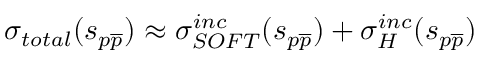<formula> <loc_0><loc_0><loc_500><loc_500>\sigma _ { t o t a l } ( s _ { p \overline { p } } ) \approx \sigma _ { S O F T } ^ { i n c } ( s _ { p \overline { p } } ) + \sigma _ { H } ^ { i n c } ( s _ { p \overline { p } } )</formula> 